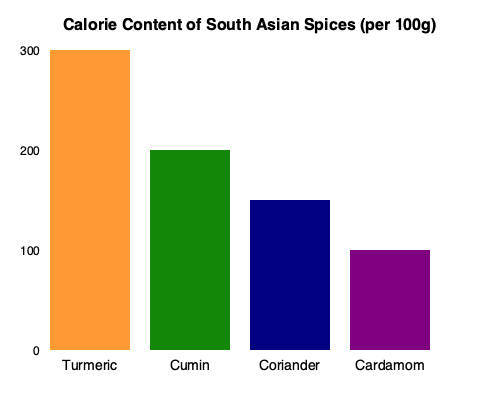Based on the bar graph showing the calorie content of different South Asian spices per 100g, calculate the percentage difference in calorie content between turmeric and cardamom. How might this information be useful when recommending recipes to clients with different nutritional needs? To calculate the percentage difference in calorie content between turmeric and cardamom, we'll follow these steps:

1. Identify the calorie content for each spice:
   Turmeric: 300 calories per 100g
   Cardamom: 100 calories per 100g

2. Calculate the difference in calories:
   $300 - 100 = 200$ calories

3. Calculate the percentage difference:
   Percentage difference = $\frac{\text{Difference}}{\text{Lower value}} \times 100\%$
   $= \frac{200}{100} \times 100\% = 200\%$

This information can be useful when recommending recipes to clients with different nutritional needs in several ways:

1. Calorie management: For clients looking to reduce calorie intake, recommending recipes that use lower-calorie spices like cardamom instead of higher-calorie options like turmeric can help create flavorful dishes with fewer calories.

2. Nutrient density: While turmeric has more calories, it's also rich in curcumin, which has anti-inflammatory properties. For clients with specific health concerns, the higher calorie content might be justified by its potential health benefits.

3. Portion control: Understanding the calorie content of spices allows for more precise portion control in recipes, especially for clients on strict calorie-controlled diets.

4. Flavor intensity: Generally, spices with higher calorie content (like turmeric) may have a more intense flavor, allowing for smaller quantities to be used while still achieving the desired taste profile.

5. Balanced meal planning: By knowing the calorie content of spices, you can better balance the overall calorie content of a meal, adjusting other ingredients accordingly to meet a client's specific calorie goals.

6. Customized recommendations: For clients with different goals (e.g., weight loss vs. muscle gain), you can recommend recipes that utilize spices that align with their specific calorie needs while still maintaining the authentic flavors of South Asian cuisine.
Answer: 200% difference; aids in calorie management, nutrient optimization, portion control, and customized meal planning for diverse client needs. 